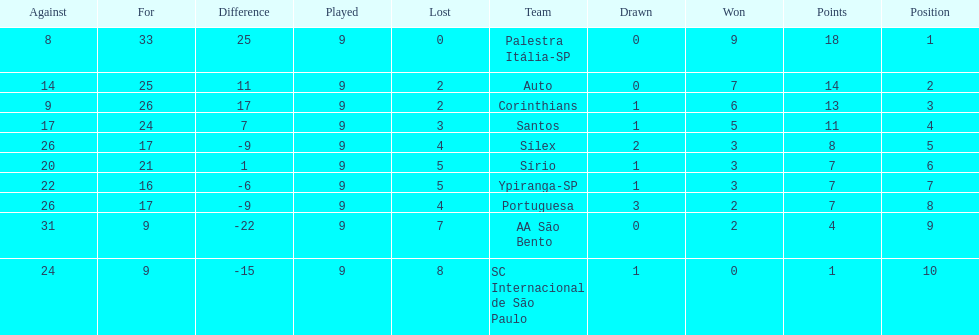How many teams had more points than silex? 4. 